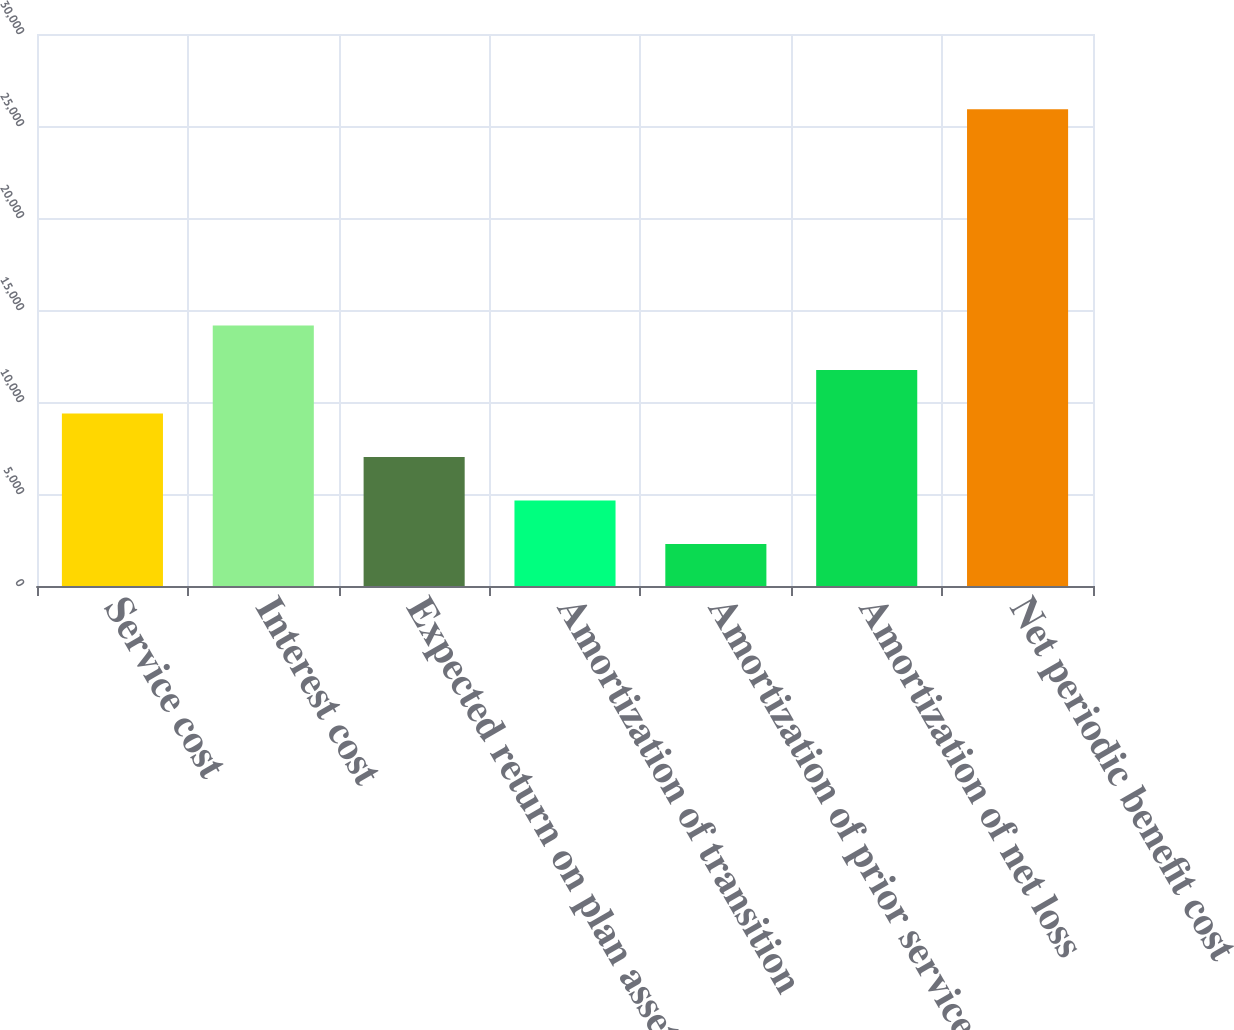Convert chart to OTSL. <chart><loc_0><loc_0><loc_500><loc_500><bar_chart><fcel>Service cost<fcel>Interest cost<fcel>Expected return on plan assets<fcel>Amortization of transition<fcel>Amortization of prior service<fcel>Amortization of net loss<fcel>Net periodic benefit cost<nl><fcel>9373.5<fcel>14156<fcel>7011<fcel>4648.5<fcel>2286<fcel>11736<fcel>25911<nl></chart> 